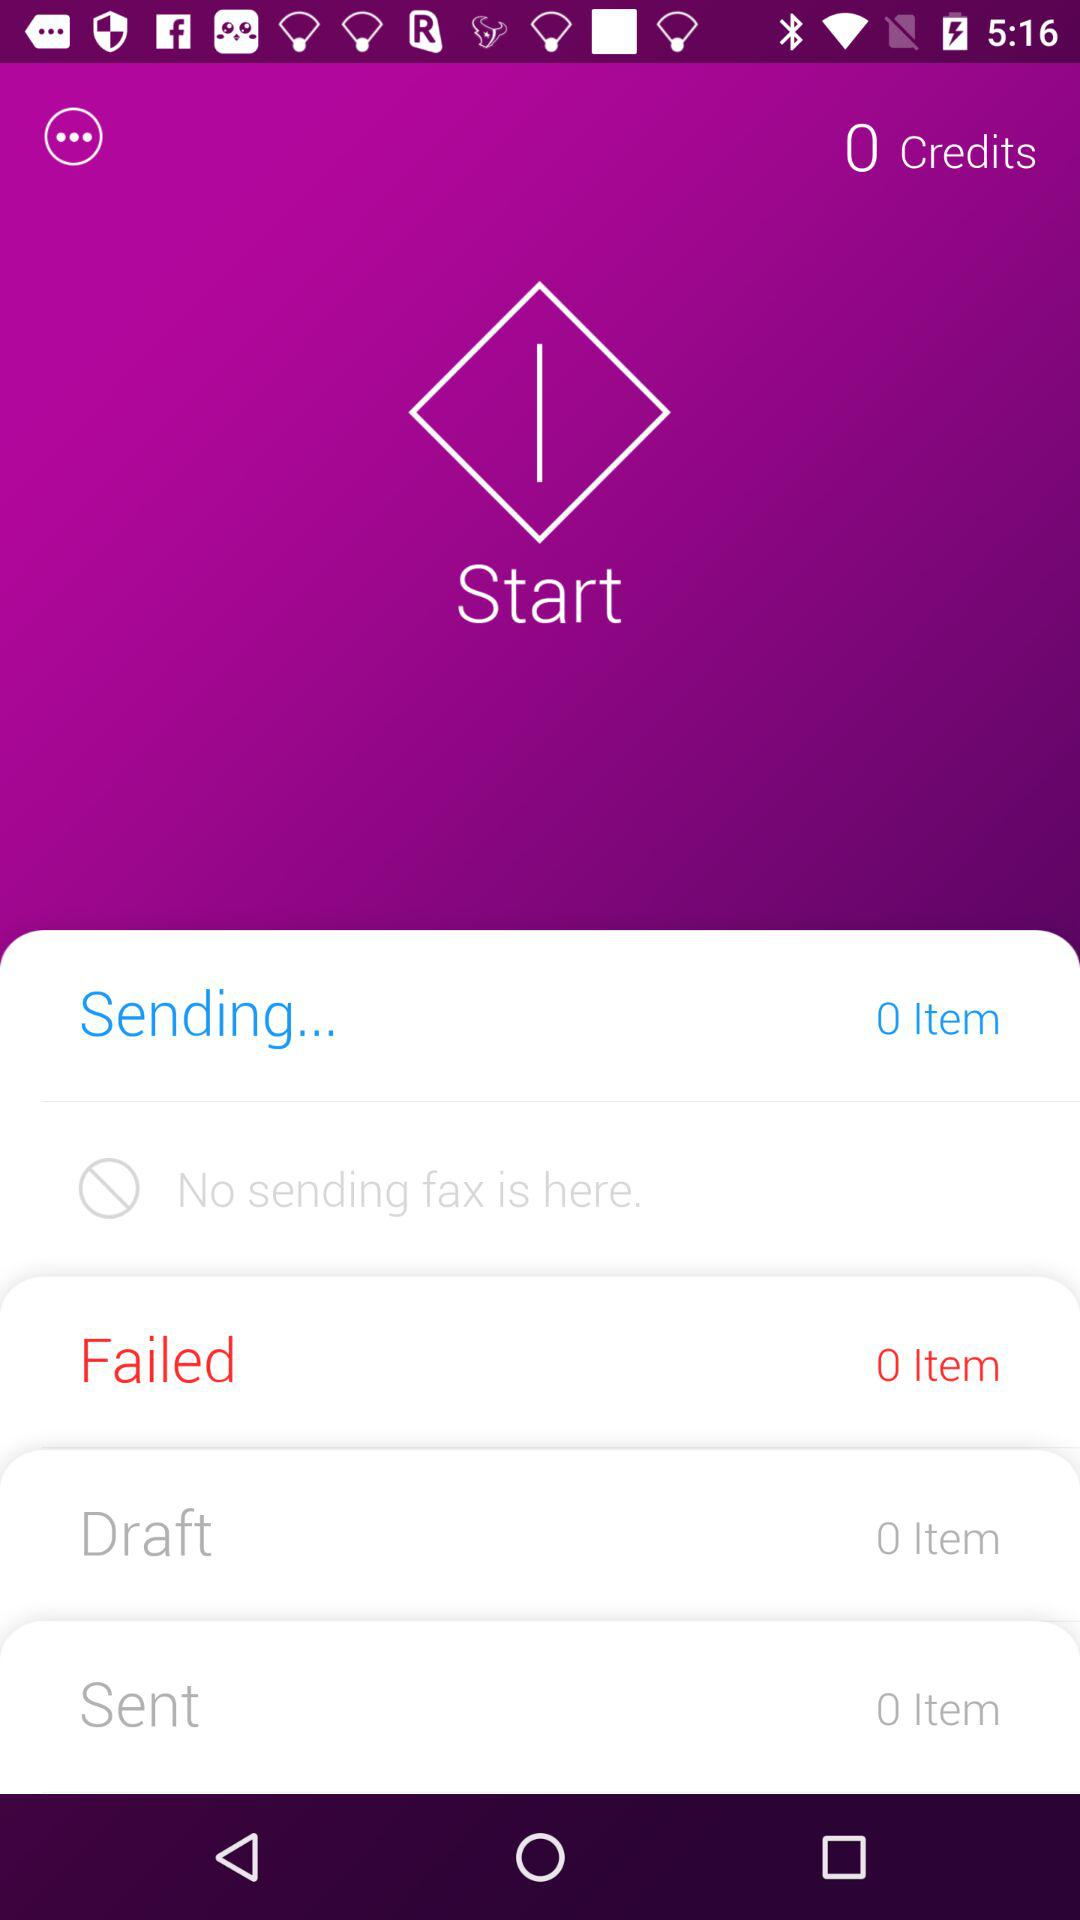What is the total number of items in "Failed"? The total number of items in "Failed" is 0. 